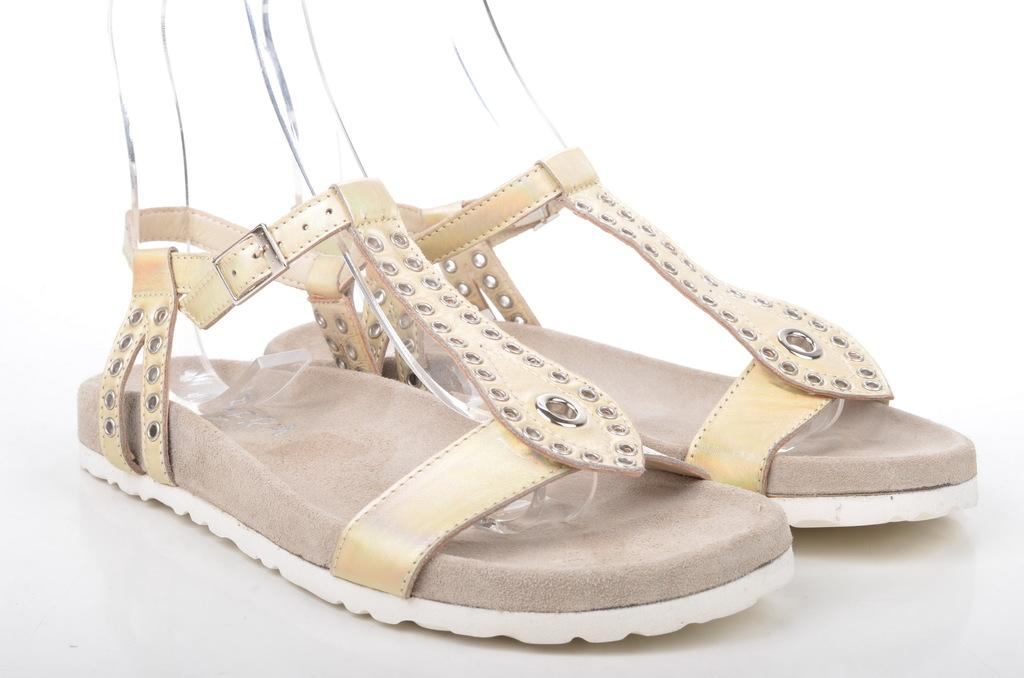What type of footwear is visible in the image? There is a pair of sandals in the image. Can you describe the sandals in more detail? Unfortunately, the image only shows a pair of sandals, and no further details are available. How many snakes are wrapped around the sandals in the image? There are no snakes present in the image; it only shows a pair of sandals. 